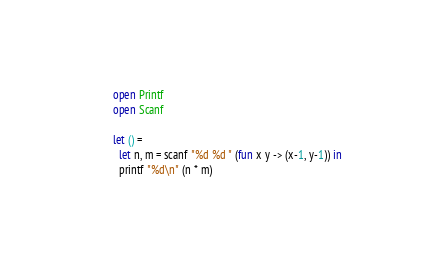<code> <loc_0><loc_0><loc_500><loc_500><_OCaml_>open Printf
open Scanf

let () =
  let n, m = scanf "%d %d " (fun x y -> (x-1, y-1)) in
  printf "%d\n" (n * m)
</code> 